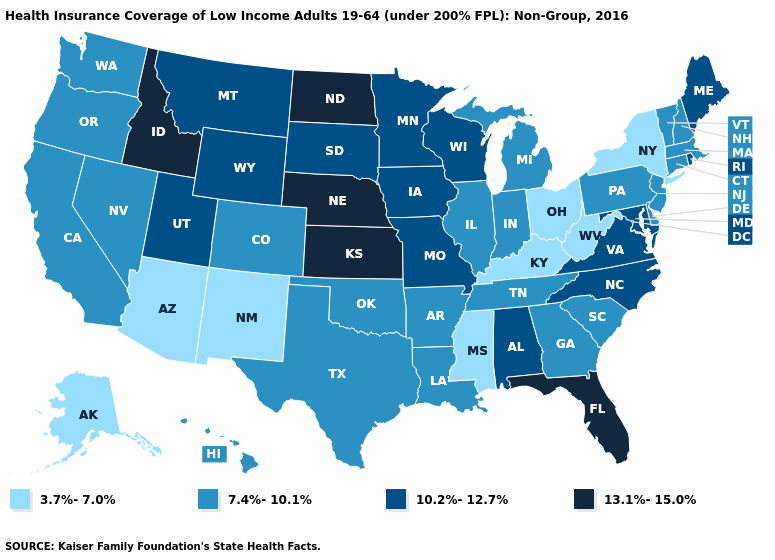Name the states that have a value in the range 3.7%-7.0%?
Keep it brief. Alaska, Arizona, Kentucky, Mississippi, New Mexico, New York, Ohio, West Virginia. What is the value of New Mexico?
Keep it brief. 3.7%-7.0%. Does Massachusetts have a higher value than New York?
Be succinct. Yes. What is the lowest value in the West?
Give a very brief answer. 3.7%-7.0%. What is the value of Minnesota?
Short answer required. 10.2%-12.7%. How many symbols are there in the legend?
Short answer required. 4. Name the states that have a value in the range 13.1%-15.0%?
Quick response, please. Florida, Idaho, Kansas, Nebraska, North Dakota. Among the states that border Louisiana , which have the highest value?
Keep it brief. Arkansas, Texas. Which states hav the highest value in the West?
Write a very short answer. Idaho. Name the states that have a value in the range 13.1%-15.0%?
Answer briefly. Florida, Idaho, Kansas, Nebraska, North Dakota. What is the value of Pennsylvania?
Concise answer only. 7.4%-10.1%. What is the value of Missouri?
Be succinct. 10.2%-12.7%. Which states hav the highest value in the Northeast?
Answer briefly. Maine, Rhode Island. What is the lowest value in the USA?
Quick response, please. 3.7%-7.0%. What is the value of Arkansas?
Short answer required. 7.4%-10.1%. 